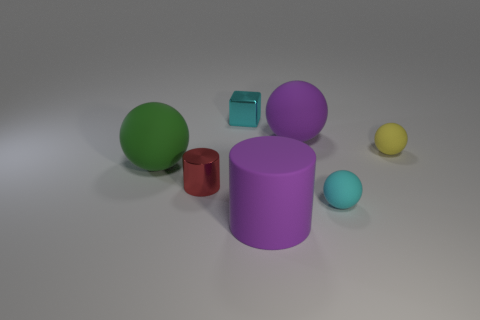Add 1 cyan things. How many objects exist? 8 Subtract all balls. How many objects are left? 3 Subtract all small green rubber things. Subtract all large objects. How many objects are left? 4 Add 2 purple rubber spheres. How many purple rubber spheres are left? 3 Add 6 small things. How many small things exist? 10 Subtract 0 red blocks. How many objects are left? 7 